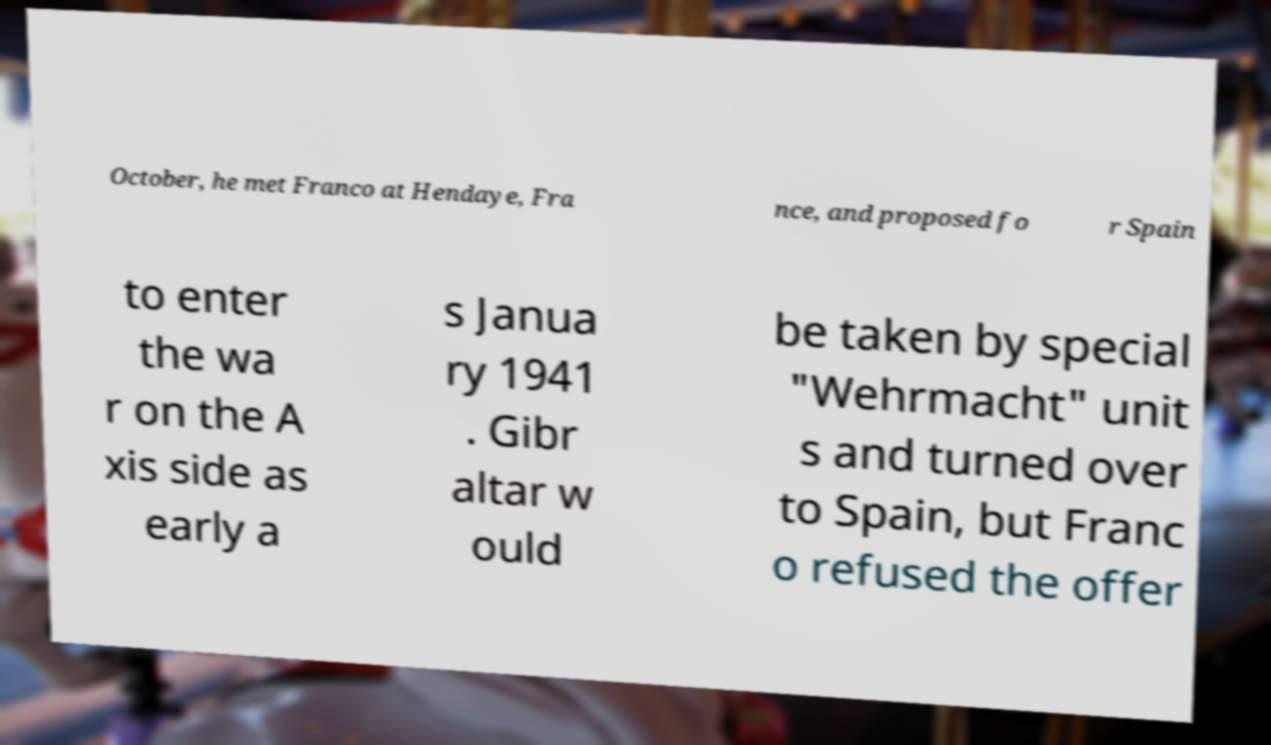Could you assist in decoding the text presented in this image and type it out clearly? October, he met Franco at Hendaye, Fra nce, and proposed fo r Spain to enter the wa r on the A xis side as early a s Janua ry 1941 . Gibr altar w ould be taken by special "Wehrmacht" unit s and turned over to Spain, but Franc o refused the offer 